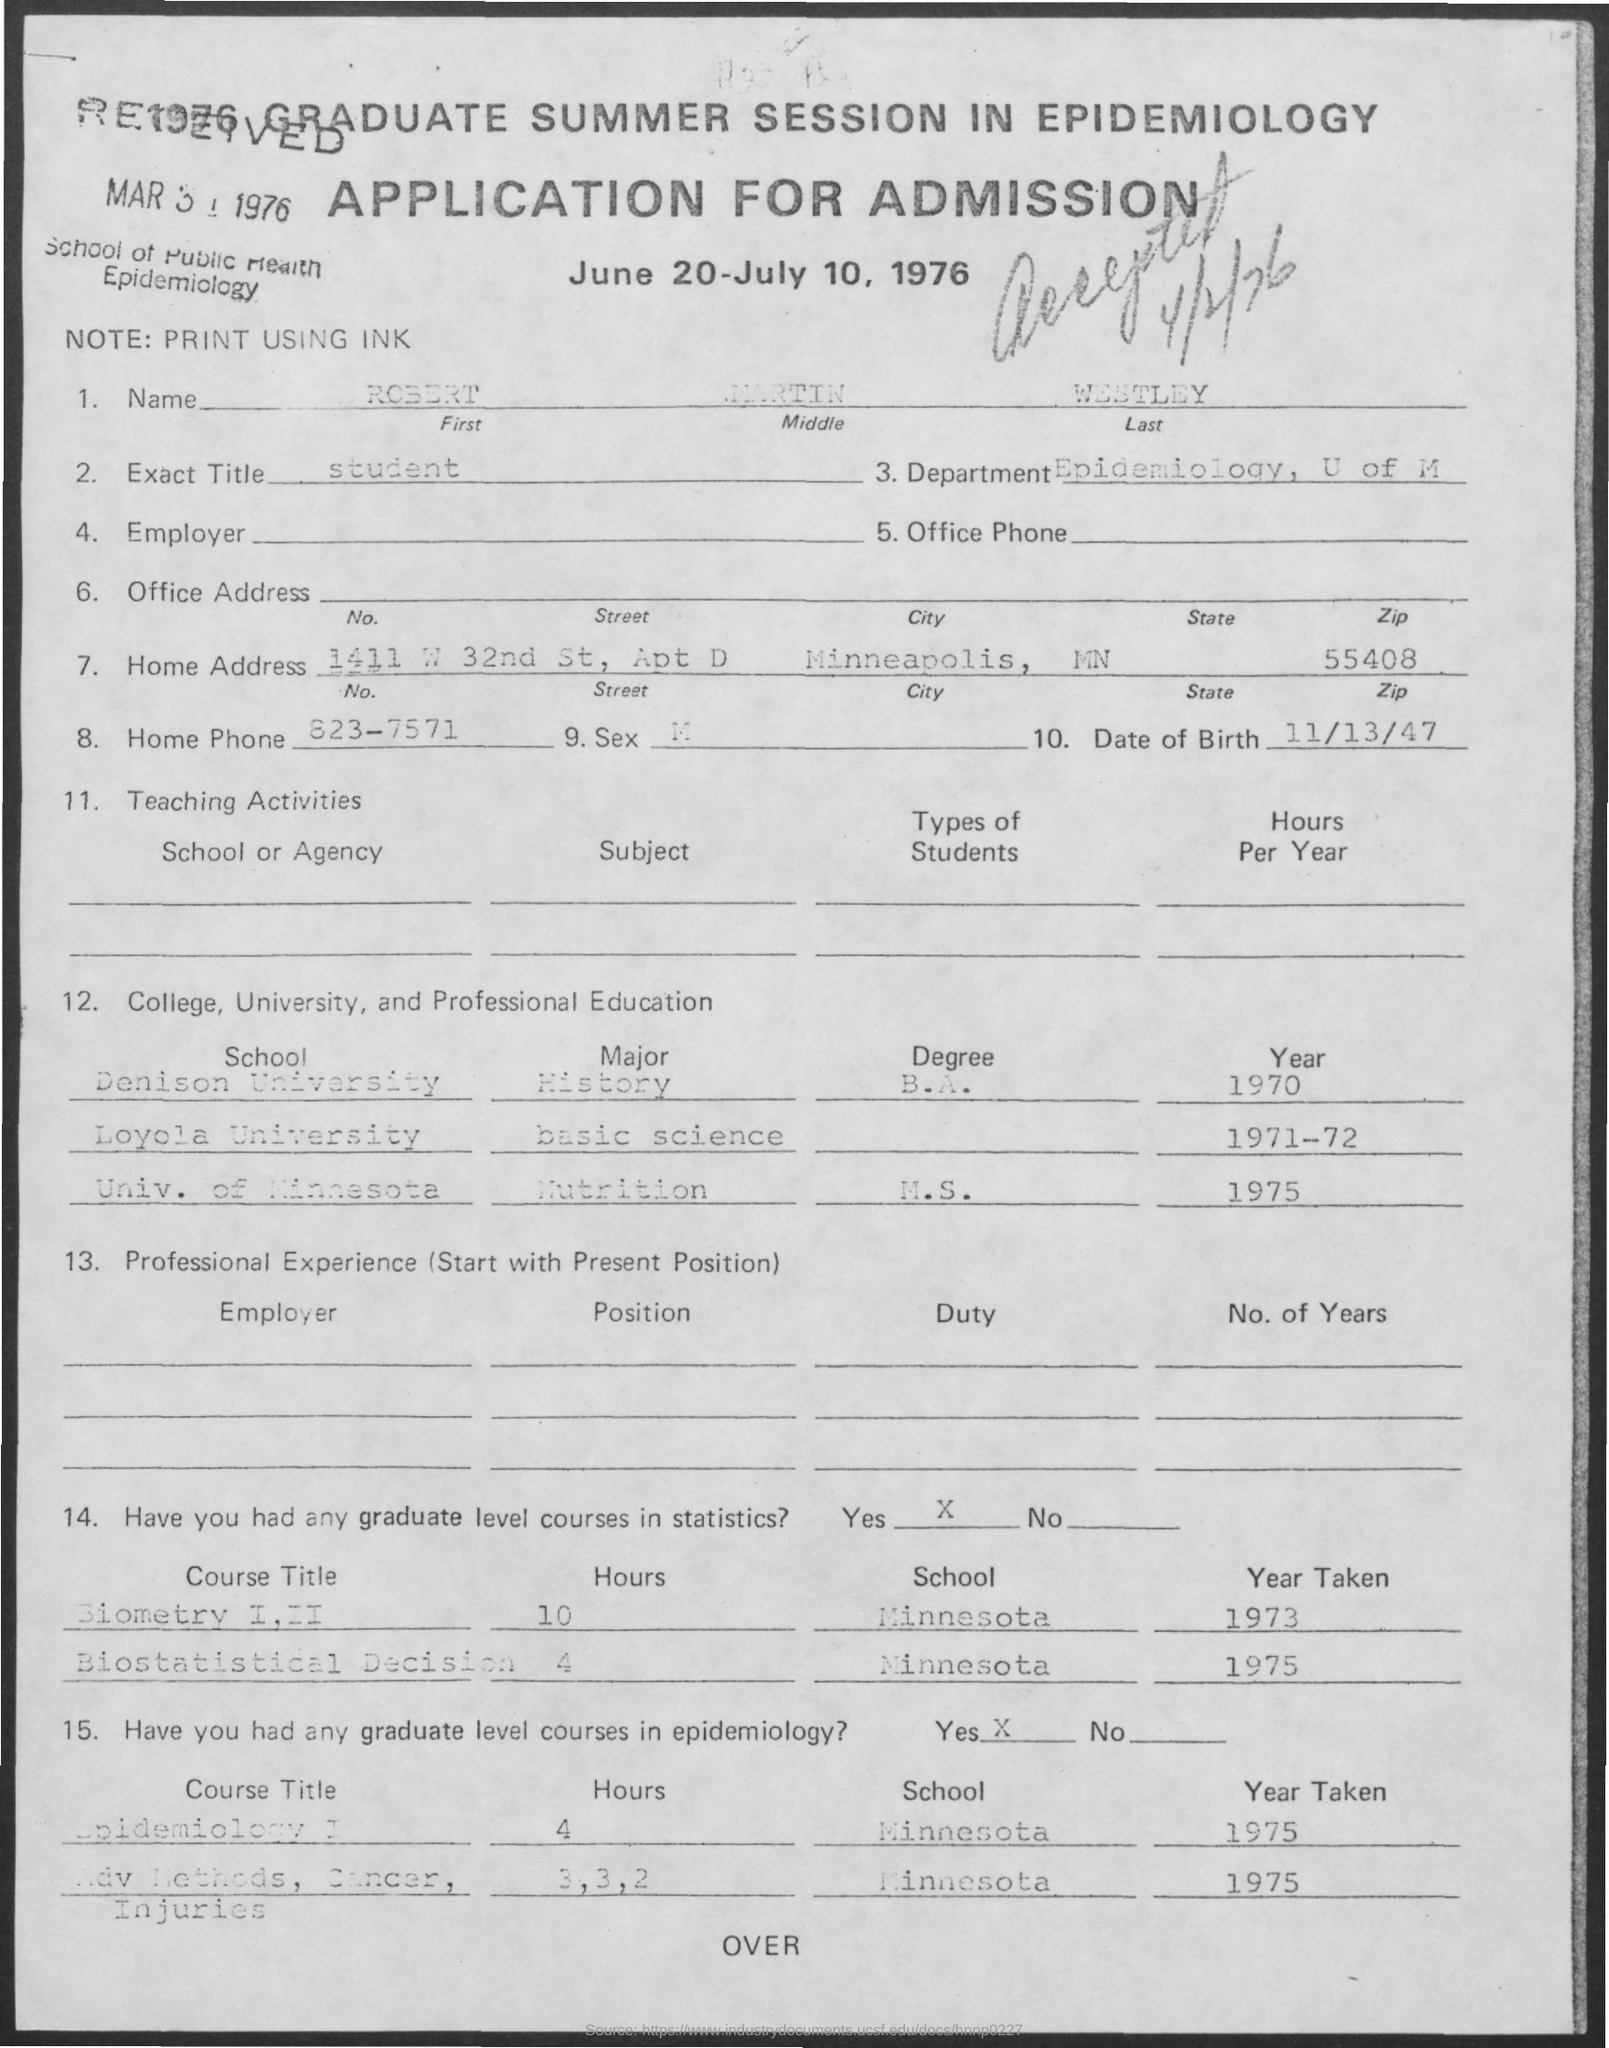What is the name mentioned ?
Provide a succinct answer. Robert Martin Westley. What is the date of birth
Your answer should be very brief. 11/13/47. What is the exact title
Offer a terse response. Student. To which department he belong to ?
Keep it short and to the point. Epidemiology, U of M. 